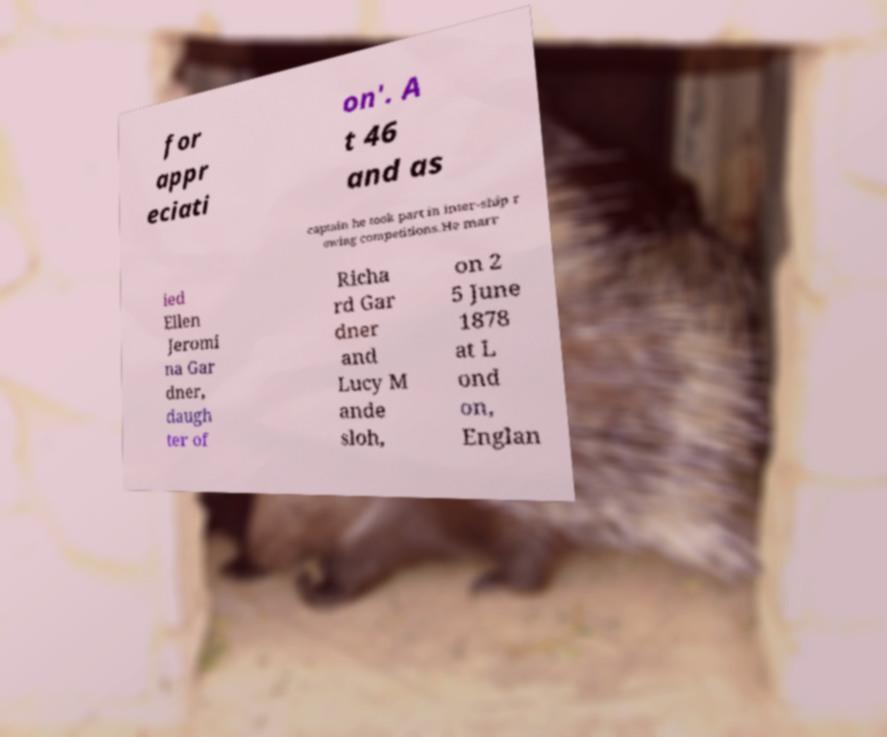Can you accurately transcribe the text from the provided image for me? for appr eciati on'. A t 46 and as captain he took part in inter-ship r owing competitions.He marr ied Ellen Jeromi na Gar dner, daugh ter of Richa rd Gar dner and Lucy M ande sloh, on 2 5 June 1878 at L ond on, Englan 